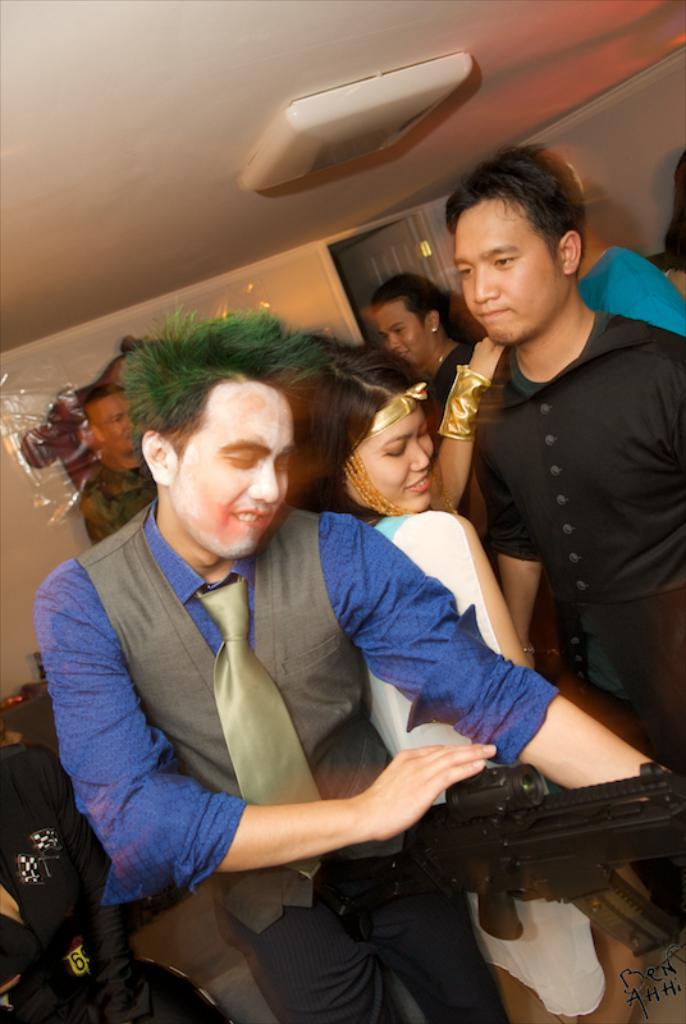What is the main subject of the image? There is a group of people in the image. Can you describe the man in the image? The man is holding a gun and smiling in the image. What can be seen in the background of the image? There is a door and walls in the background of the image. How many buckets of water can be seen in the image? There are no buckets of water present in the image. What type of boundary is visible in the image? There is no boundary visible in the image. 